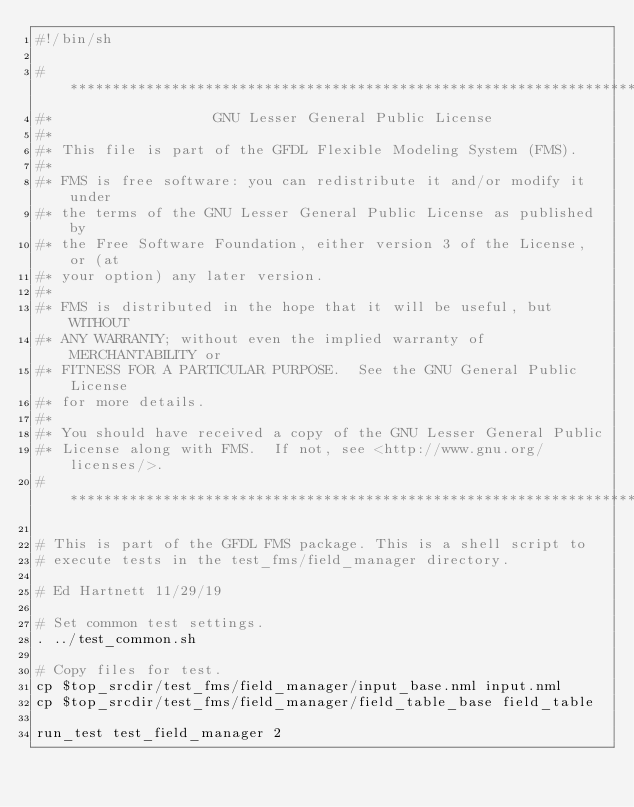<code> <loc_0><loc_0><loc_500><loc_500><_Bash_>#!/bin/sh

#***********************************************************************
#*                   GNU Lesser General Public License
#*
#* This file is part of the GFDL Flexible Modeling System (FMS).
#*
#* FMS is free software: you can redistribute it and/or modify it under
#* the terms of the GNU Lesser General Public License as published by
#* the Free Software Foundation, either version 3 of the License, or (at
#* your option) any later version.
#*
#* FMS is distributed in the hope that it will be useful, but WITHOUT
#* ANY WARRANTY; without even the implied warranty of MERCHANTABILITY or
#* FITNESS FOR A PARTICULAR PURPOSE.  See the GNU General Public License
#* for more details.
#*
#* You should have received a copy of the GNU Lesser General Public
#* License along with FMS.  If not, see <http://www.gnu.org/licenses/>.
#***********************************************************************

# This is part of the GFDL FMS package. This is a shell script to
# execute tests in the test_fms/field_manager directory.

# Ed Hartnett 11/29/19

# Set common test settings.
. ../test_common.sh

# Copy files for test.
cp $top_srcdir/test_fms/field_manager/input_base.nml input.nml
cp $top_srcdir/test_fms/field_manager/field_table_base field_table

run_test test_field_manager 2
</code> 